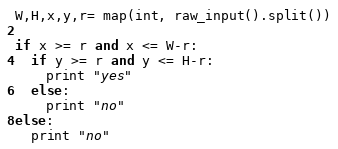Convert code to text. <code><loc_0><loc_0><loc_500><loc_500><_Python_>W,H,x,y,r= map(int, raw_input().split())

if x >= r and x <= W-r:
  if y >= r and y <= H-r:
    print "yes"
  else:
    print "no"
else:
  print "no"</code> 